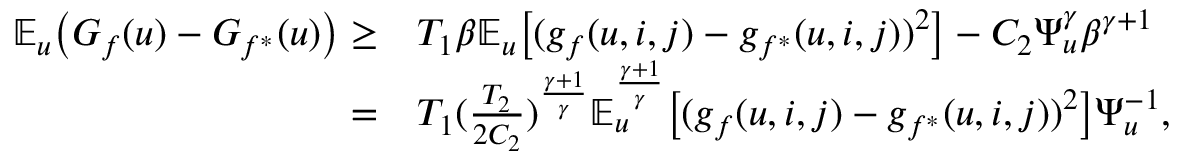Convert formula to latex. <formula><loc_0><loc_0><loc_500><loc_500>\begin{array} { r l } { \mathbb { E } _ { u } \left ( G _ { f } ( u ) - G _ { f ^ { * } } ( u ) \right ) \geq } & { T _ { 1 } \beta \mathbb { E } _ { u } \left [ ( g _ { f } ( u , i , j ) - g _ { f ^ { * } } ( u , i , j ) ) ^ { 2 } \right ] - C _ { 2 } \Psi _ { u } ^ { \gamma } \beta ^ { \gamma + 1 } } \\ { = } & { T _ { 1 } ( \frac { T _ { 2 } } { 2 C _ { 2 } } ) ^ { \frac { \gamma + 1 } { \gamma } } \mathbb { E } _ { u } ^ { \frac { \gamma + 1 } { \gamma } } \left [ ( g _ { f } ( u , i , j ) - g _ { f ^ { * } } ( u , i , j ) ) ^ { 2 } \right ] \Psi _ { u } ^ { - 1 } , } \end{array}</formula> 